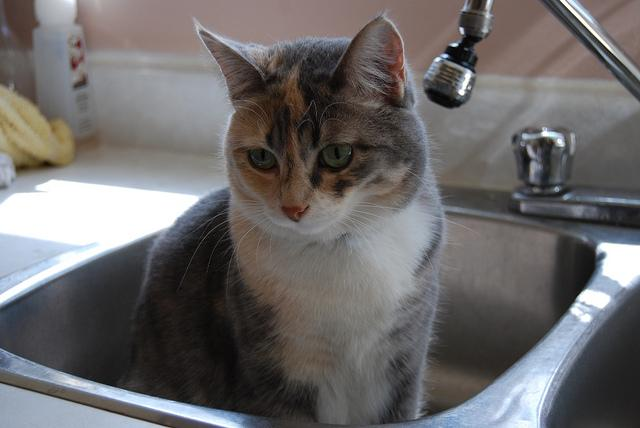What material is the sink made of?

Choices:
A) porcelain
B) plastic
C) wood
D) stainless steel stainless steel 